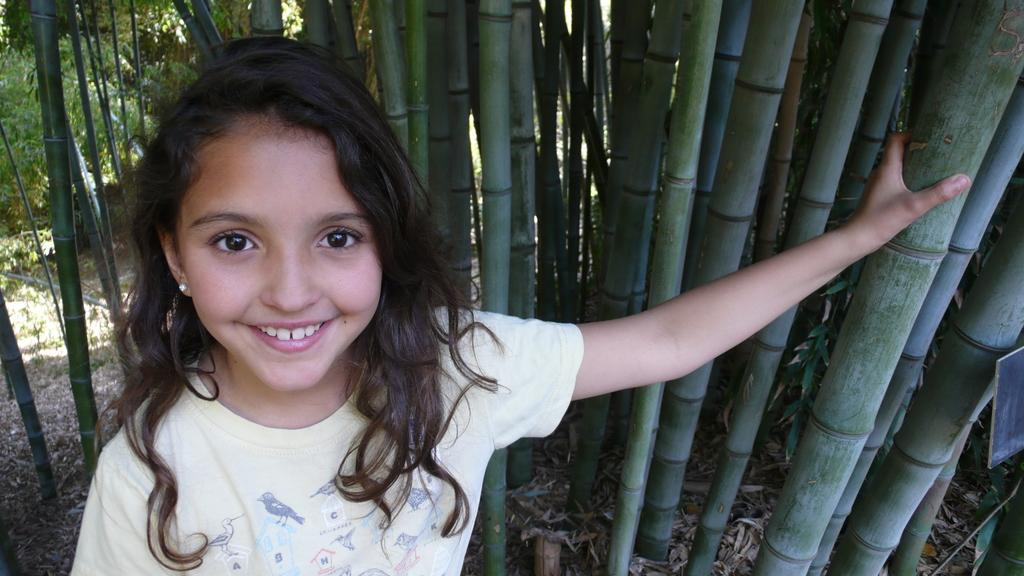Who is the main subject in the image? There is a girl in the image. Where is the girl located in the image? The girl is on the left side of the image. What expression does the girl have? The girl is smiling. What type of vegetation is on the right side of the image? There are bamboo trees on the right side of the image. What type of bottle can be seen in the girl's hand in the image? There is no bottle present in the girl's hand or in the image. 